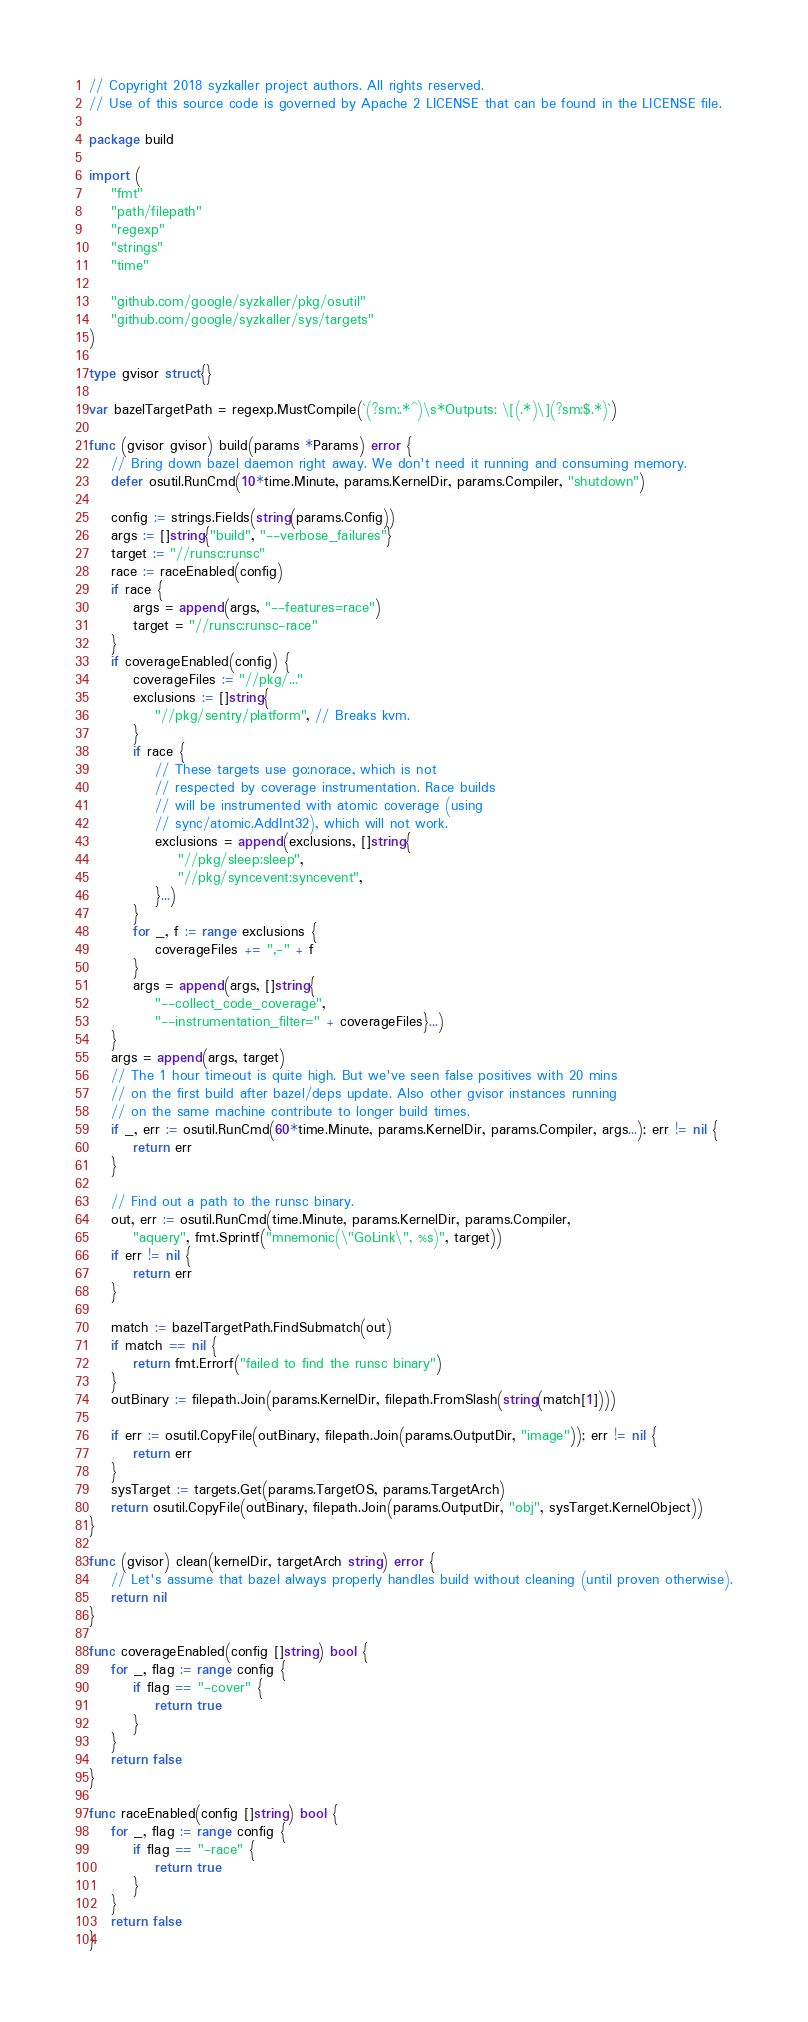Convert code to text. <code><loc_0><loc_0><loc_500><loc_500><_Go_>// Copyright 2018 syzkaller project authors. All rights reserved.
// Use of this source code is governed by Apache 2 LICENSE that can be found in the LICENSE file.

package build

import (
	"fmt"
	"path/filepath"
	"regexp"
	"strings"
	"time"

	"github.com/google/syzkaller/pkg/osutil"
	"github.com/google/syzkaller/sys/targets"
)

type gvisor struct{}

var bazelTargetPath = regexp.MustCompile(`(?sm:.*^)\s*Outputs: \[(.*)\](?sm:$.*)`)

func (gvisor gvisor) build(params *Params) error {
	// Bring down bazel daemon right away. We don't need it running and consuming memory.
	defer osutil.RunCmd(10*time.Minute, params.KernelDir, params.Compiler, "shutdown")

	config := strings.Fields(string(params.Config))
	args := []string{"build", "--verbose_failures"}
	target := "//runsc:runsc"
	race := raceEnabled(config)
	if race {
		args = append(args, "--features=race")
		target = "//runsc:runsc-race"
	}
	if coverageEnabled(config) {
		coverageFiles := "//pkg/..."
		exclusions := []string{
			"//pkg/sentry/platform", // Breaks kvm.
		}
		if race {
			// These targets use go:norace, which is not
			// respected by coverage instrumentation. Race builds
			// will be instrumented with atomic coverage (using
			// sync/atomic.AddInt32), which will not work.
			exclusions = append(exclusions, []string{
				"//pkg/sleep:sleep",
				"//pkg/syncevent:syncevent",
			}...)
		}
		for _, f := range exclusions {
			coverageFiles += ",-" + f
		}
		args = append(args, []string{
			"--collect_code_coverage",
			"--instrumentation_filter=" + coverageFiles}...)
	}
	args = append(args, target)
	// The 1 hour timeout is quite high. But we've seen false positives with 20 mins
	// on the first build after bazel/deps update. Also other gvisor instances running
	// on the same machine contribute to longer build times.
	if _, err := osutil.RunCmd(60*time.Minute, params.KernelDir, params.Compiler, args...); err != nil {
		return err
	}

	// Find out a path to the runsc binary.
	out, err := osutil.RunCmd(time.Minute, params.KernelDir, params.Compiler,
		"aquery", fmt.Sprintf("mnemonic(\"GoLink\", %s)", target))
	if err != nil {
		return err
	}

	match := bazelTargetPath.FindSubmatch(out)
	if match == nil {
		return fmt.Errorf("failed to find the runsc binary")
	}
	outBinary := filepath.Join(params.KernelDir, filepath.FromSlash(string(match[1])))

	if err := osutil.CopyFile(outBinary, filepath.Join(params.OutputDir, "image")); err != nil {
		return err
	}
	sysTarget := targets.Get(params.TargetOS, params.TargetArch)
	return osutil.CopyFile(outBinary, filepath.Join(params.OutputDir, "obj", sysTarget.KernelObject))
}

func (gvisor) clean(kernelDir, targetArch string) error {
	// Let's assume that bazel always properly handles build without cleaning (until proven otherwise).
	return nil
}

func coverageEnabled(config []string) bool {
	for _, flag := range config {
		if flag == "-cover" {
			return true
		}
	}
	return false
}

func raceEnabled(config []string) bool {
	for _, flag := range config {
		if flag == "-race" {
			return true
		}
	}
	return false
}
</code> 